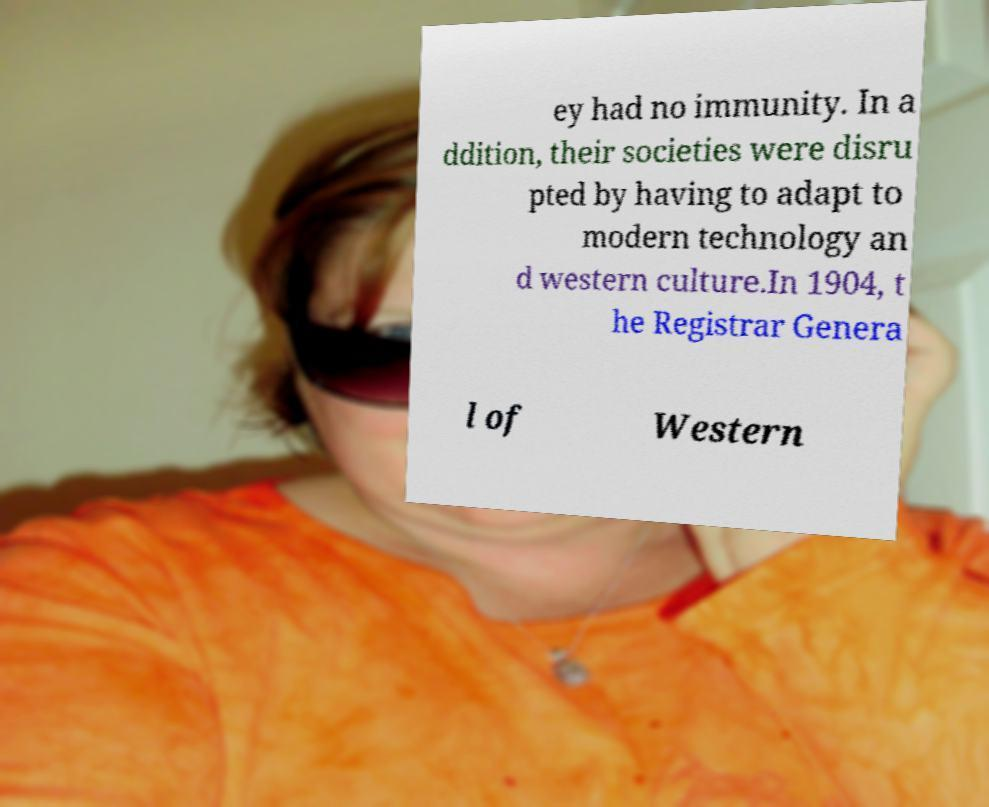Can you accurately transcribe the text from the provided image for me? ey had no immunity. In a ddition, their societies were disru pted by having to adapt to modern technology an d western culture.In 1904, t he Registrar Genera l of Western 